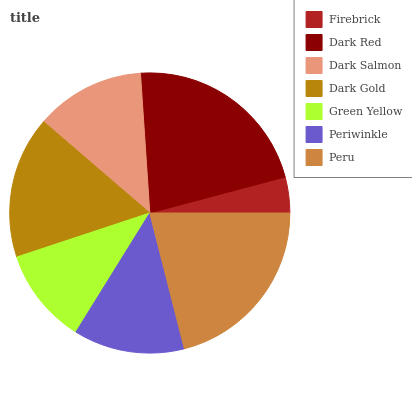Is Firebrick the minimum?
Answer yes or no. Yes. Is Dark Red the maximum?
Answer yes or no. Yes. Is Dark Salmon the minimum?
Answer yes or no. No. Is Dark Salmon the maximum?
Answer yes or no. No. Is Dark Red greater than Dark Salmon?
Answer yes or no. Yes. Is Dark Salmon less than Dark Red?
Answer yes or no. Yes. Is Dark Salmon greater than Dark Red?
Answer yes or no. No. Is Dark Red less than Dark Salmon?
Answer yes or no. No. Is Periwinkle the high median?
Answer yes or no. Yes. Is Periwinkle the low median?
Answer yes or no. Yes. Is Firebrick the high median?
Answer yes or no. No. Is Peru the low median?
Answer yes or no. No. 